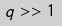Convert formula to latex. <formula><loc_0><loc_0><loc_500><loc_500>q > > 1</formula> 